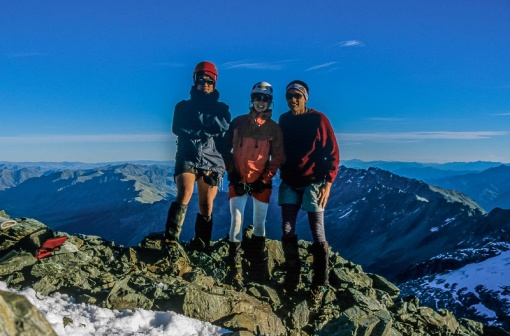What challenges do you think these adventurers might have faced on their journey? These adventurers likely encountered a range of challenges on their journey. The rocky and uneven terrain would require careful navigation, and the elevation suggests that they faced steep climbs and possibly treacherous descents. The weather, while clear in the photograph, could have varied drastically, with cold temperatures, strong winds, and the potential for sudden storms, making their trek more difficult. They also needed to be vigilant about altitude sickness, requiring acclimatization to avoid dizziness, headaches, or more serious symptoms. Their presence on the summit reflects not just physical endurance but also mental resilience, teamwork, and precise planning. 